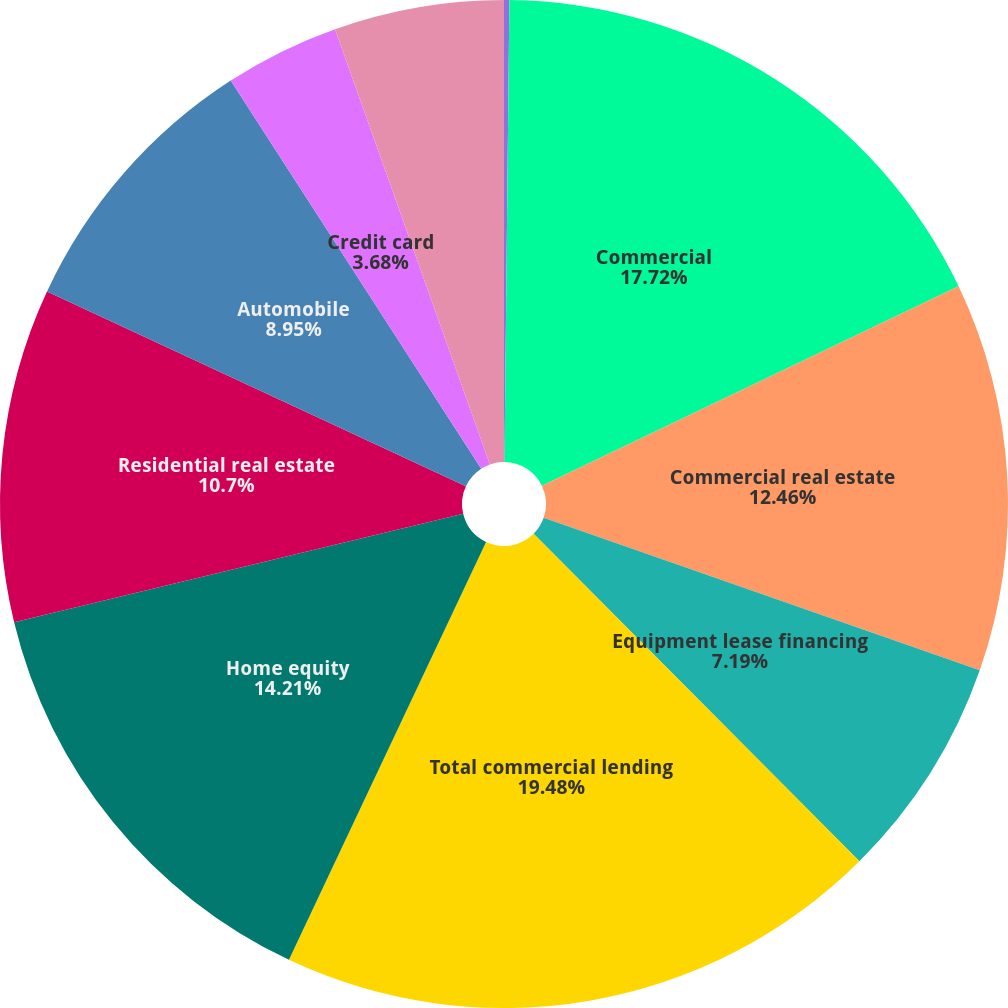Convert chart to OTSL. <chart><loc_0><loc_0><loc_500><loc_500><pie_chart><fcel>December 31 - in millions<fcel>Commercial<fcel>Commercial real estate<fcel>Equipment lease financing<fcel>Total commercial lending<fcel>Home equity<fcel>Residential real estate<fcel>Automobile<fcel>Credit card<fcel>Education<nl><fcel>0.17%<fcel>17.72%<fcel>12.46%<fcel>7.19%<fcel>19.47%<fcel>14.21%<fcel>10.7%<fcel>8.95%<fcel>3.68%<fcel>5.44%<nl></chart> 